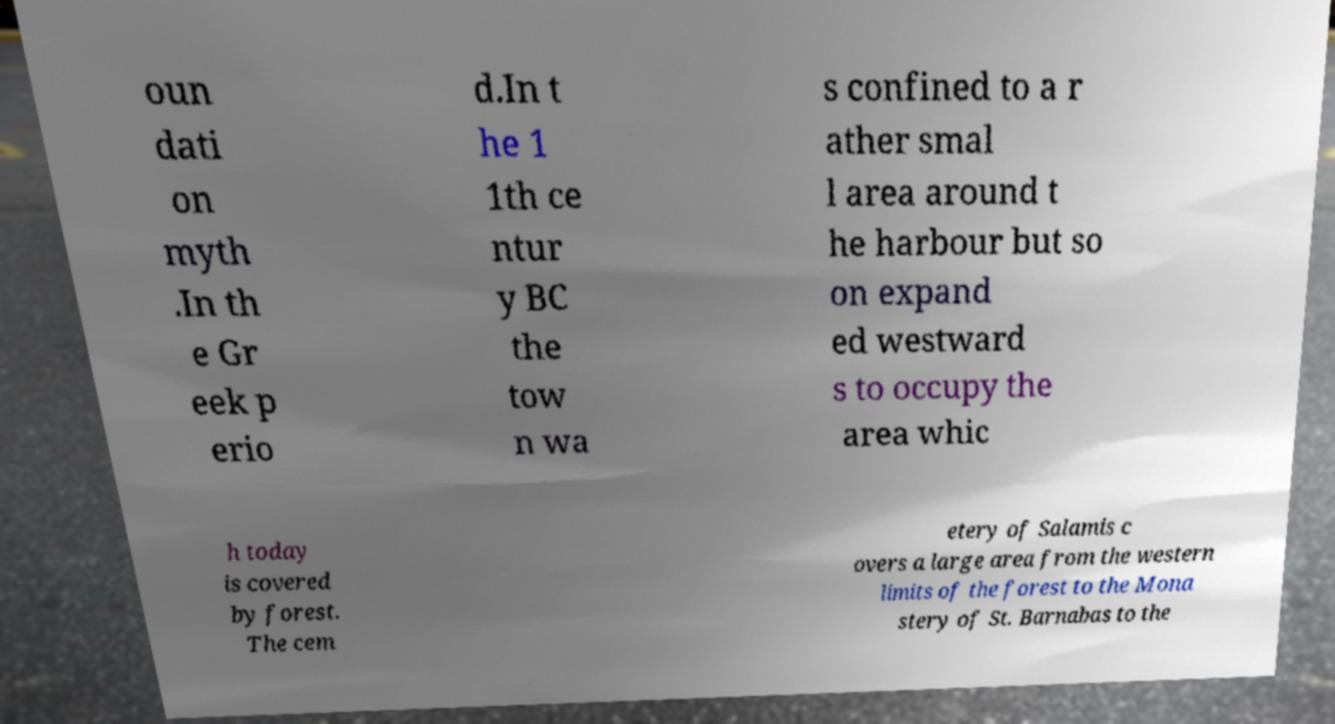Please read and relay the text visible in this image. What does it say? oun dati on myth .In th e Gr eek p erio d.In t he 1 1th ce ntur y BC the tow n wa s confined to a r ather smal l area around t he harbour but so on expand ed westward s to occupy the area whic h today is covered by forest. The cem etery of Salamis c overs a large area from the western limits of the forest to the Mona stery of St. Barnabas to the 